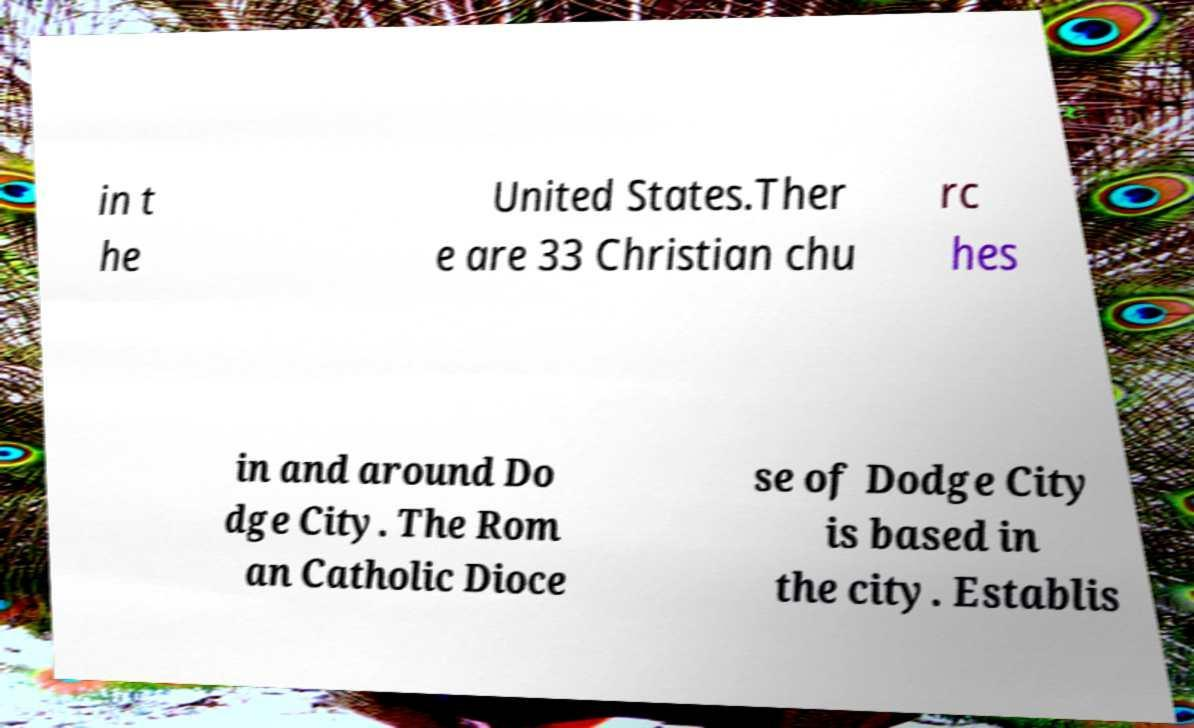For documentation purposes, I need the text within this image transcribed. Could you provide that? in t he United States.Ther e are 33 Christian chu rc hes in and around Do dge City. The Rom an Catholic Dioce se of Dodge City is based in the city. Establis 